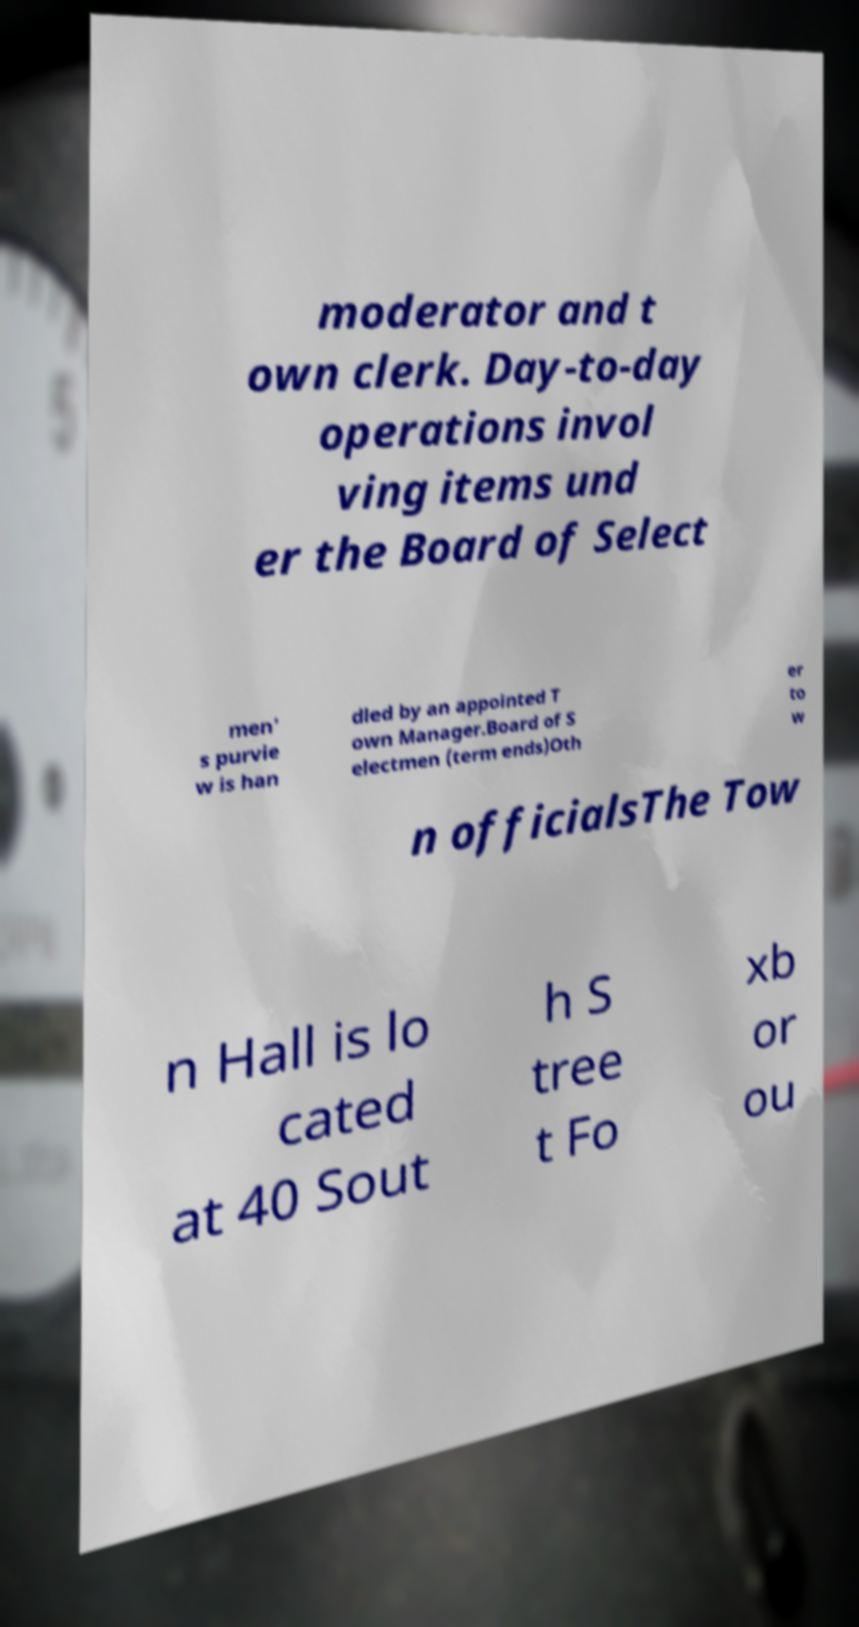There's text embedded in this image that I need extracted. Can you transcribe it verbatim? moderator and t own clerk. Day-to-day operations invol ving items und er the Board of Select men' s purvie w is han dled by an appointed T own Manager.Board of S electmen (term ends)Oth er to w n officialsThe Tow n Hall is lo cated at 40 Sout h S tree t Fo xb or ou 